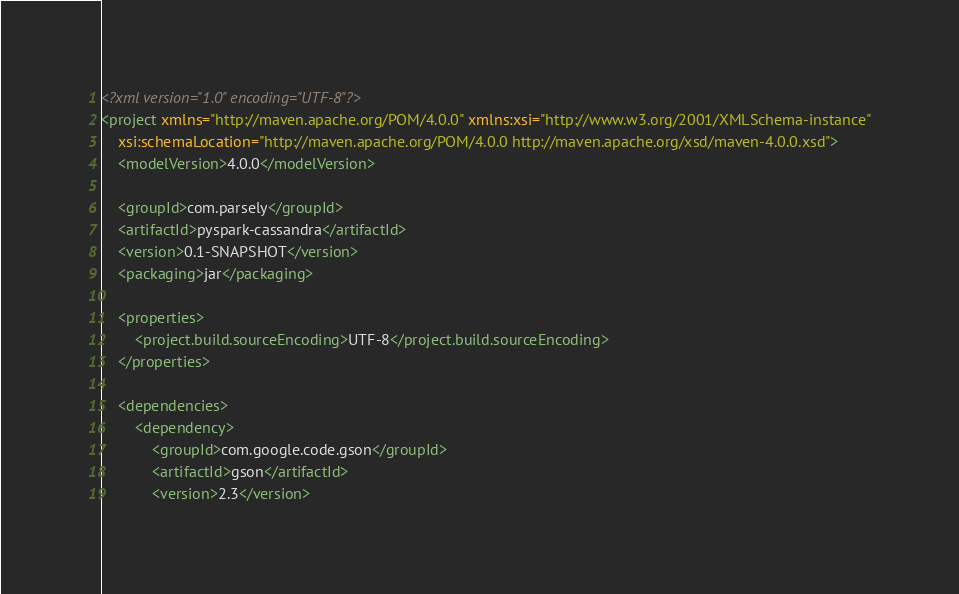<code> <loc_0><loc_0><loc_500><loc_500><_XML_><?xml version="1.0" encoding="UTF-8"?>
<project xmlns="http://maven.apache.org/POM/4.0.0" xmlns:xsi="http://www.w3.org/2001/XMLSchema-instance"
    xsi:schemaLocation="http://maven.apache.org/POM/4.0.0 http://maven.apache.org/xsd/maven-4.0.0.xsd">
    <modelVersion>4.0.0</modelVersion>

    <groupId>com.parsely</groupId>
    <artifactId>pyspark-cassandra</artifactId>
    <version>0.1-SNAPSHOT</version>
    <packaging>jar</packaging>

    <properties>
        <project.build.sourceEncoding>UTF-8</project.build.sourceEncoding>
    </properties>

    <dependencies>
        <dependency>
            <groupId>com.google.code.gson</groupId>
            <artifactId>gson</artifactId>
            <version>2.3</version></code> 